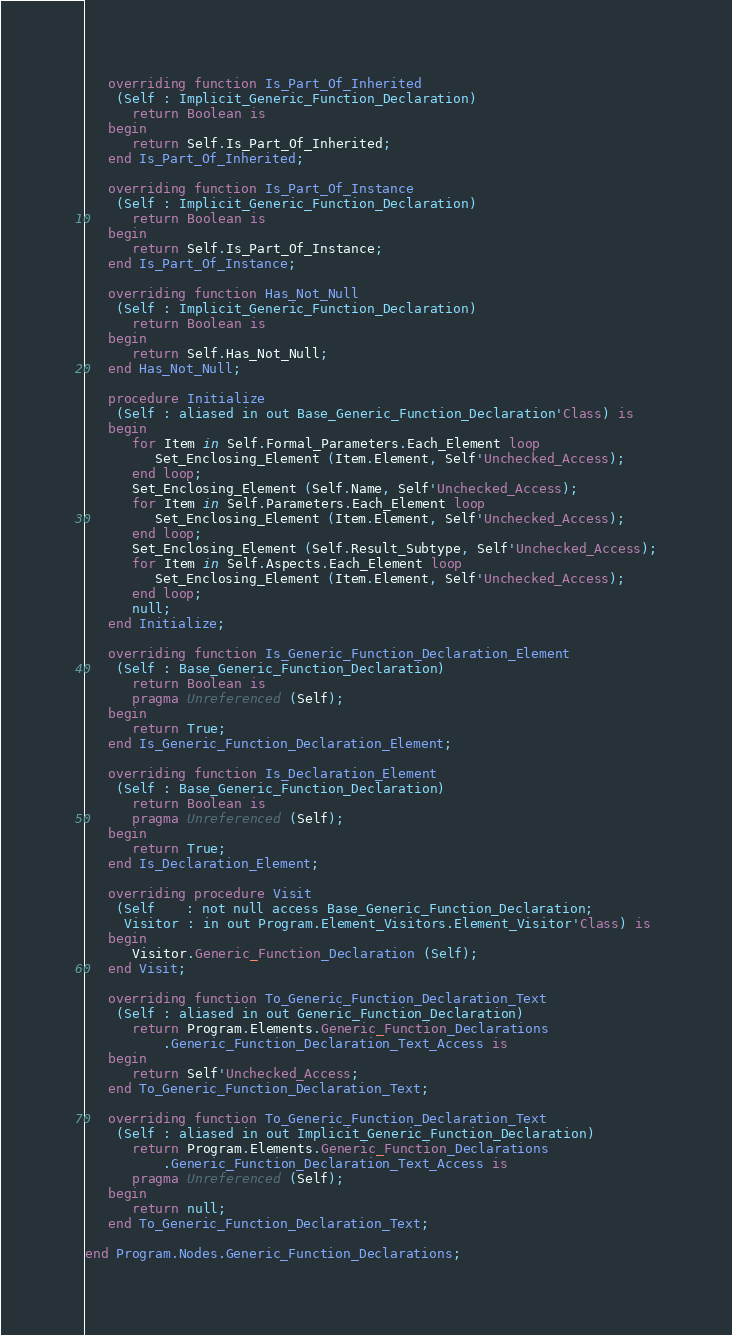<code> <loc_0><loc_0><loc_500><loc_500><_Ada_>
   overriding function Is_Part_Of_Inherited
    (Self : Implicit_Generic_Function_Declaration)
      return Boolean is
   begin
      return Self.Is_Part_Of_Inherited;
   end Is_Part_Of_Inherited;

   overriding function Is_Part_Of_Instance
    (Self : Implicit_Generic_Function_Declaration)
      return Boolean is
   begin
      return Self.Is_Part_Of_Instance;
   end Is_Part_Of_Instance;

   overriding function Has_Not_Null
    (Self : Implicit_Generic_Function_Declaration)
      return Boolean is
   begin
      return Self.Has_Not_Null;
   end Has_Not_Null;

   procedure Initialize
    (Self : aliased in out Base_Generic_Function_Declaration'Class) is
   begin
      for Item in Self.Formal_Parameters.Each_Element loop
         Set_Enclosing_Element (Item.Element, Self'Unchecked_Access);
      end loop;
      Set_Enclosing_Element (Self.Name, Self'Unchecked_Access);
      for Item in Self.Parameters.Each_Element loop
         Set_Enclosing_Element (Item.Element, Self'Unchecked_Access);
      end loop;
      Set_Enclosing_Element (Self.Result_Subtype, Self'Unchecked_Access);
      for Item in Self.Aspects.Each_Element loop
         Set_Enclosing_Element (Item.Element, Self'Unchecked_Access);
      end loop;
      null;
   end Initialize;

   overriding function Is_Generic_Function_Declaration_Element
    (Self : Base_Generic_Function_Declaration)
      return Boolean is
      pragma Unreferenced (Self);
   begin
      return True;
   end Is_Generic_Function_Declaration_Element;

   overriding function Is_Declaration_Element
    (Self : Base_Generic_Function_Declaration)
      return Boolean is
      pragma Unreferenced (Self);
   begin
      return True;
   end Is_Declaration_Element;

   overriding procedure Visit
    (Self    : not null access Base_Generic_Function_Declaration;
     Visitor : in out Program.Element_Visitors.Element_Visitor'Class) is
   begin
      Visitor.Generic_Function_Declaration (Self);
   end Visit;

   overriding function To_Generic_Function_Declaration_Text
    (Self : aliased in out Generic_Function_Declaration)
      return Program.Elements.Generic_Function_Declarations
          .Generic_Function_Declaration_Text_Access is
   begin
      return Self'Unchecked_Access;
   end To_Generic_Function_Declaration_Text;

   overriding function To_Generic_Function_Declaration_Text
    (Self : aliased in out Implicit_Generic_Function_Declaration)
      return Program.Elements.Generic_Function_Declarations
          .Generic_Function_Declaration_Text_Access is
      pragma Unreferenced (Self);
   begin
      return null;
   end To_Generic_Function_Declaration_Text;

end Program.Nodes.Generic_Function_Declarations;
</code> 